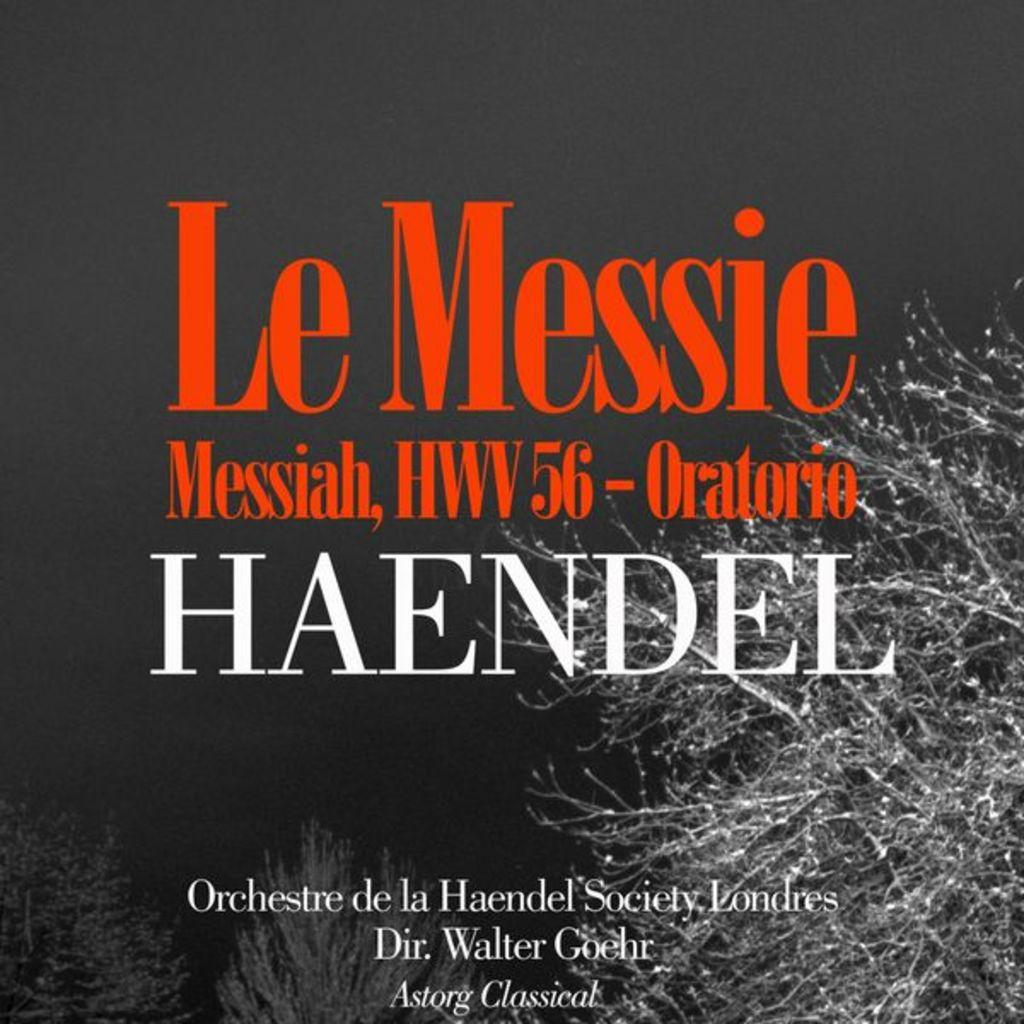Provide a one-sentence caption for the provided image. A flyer shows Le Messie Messiah by Haendel on it. 